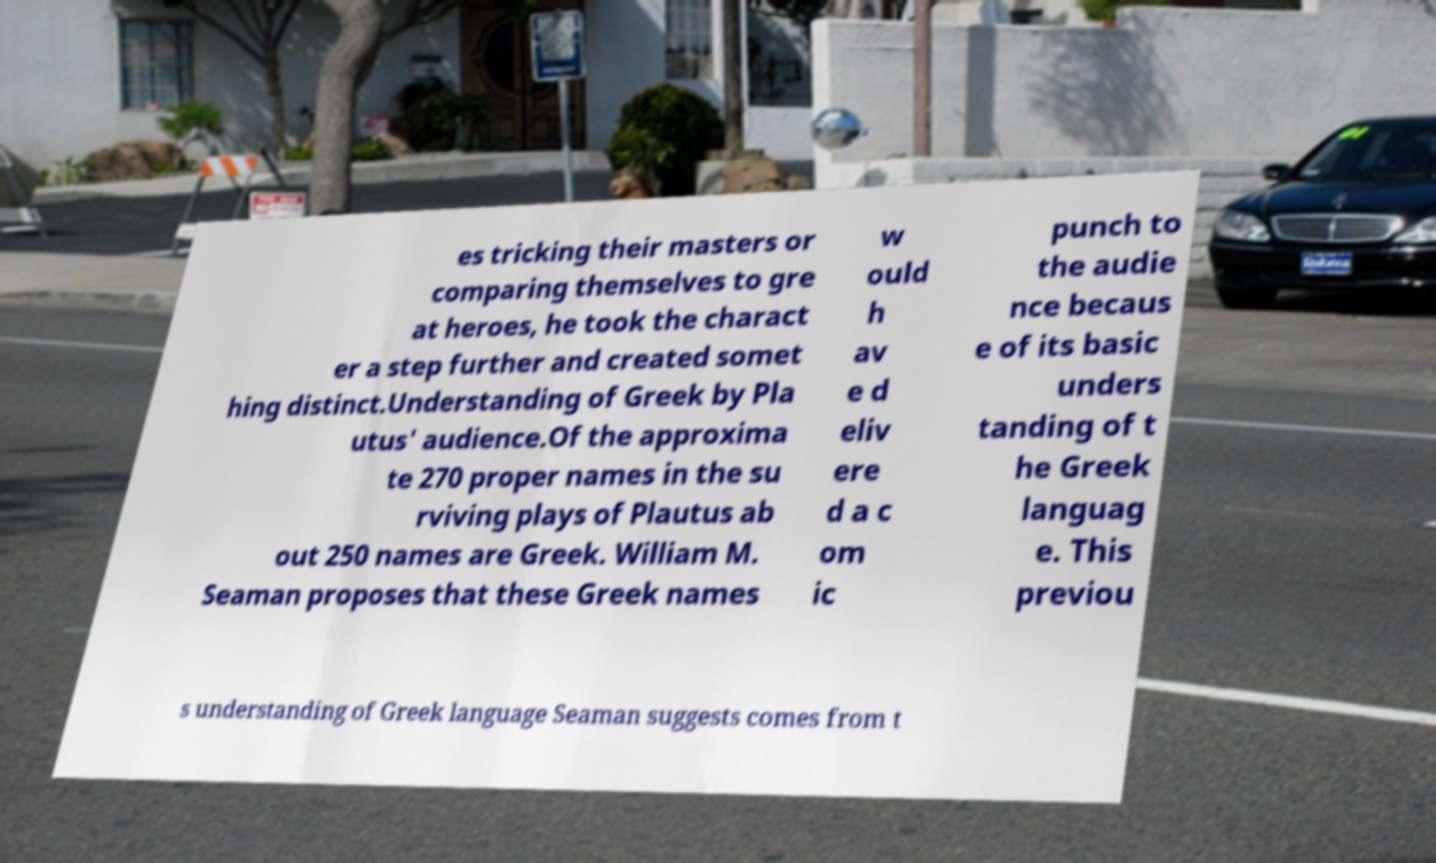Could you assist in decoding the text presented in this image and type it out clearly? es tricking their masters or comparing themselves to gre at heroes, he took the charact er a step further and created somet hing distinct.Understanding of Greek by Pla utus' audience.Of the approxima te 270 proper names in the su rviving plays of Plautus ab out 250 names are Greek. William M. Seaman proposes that these Greek names w ould h av e d eliv ere d a c om ic punch to the audie nce becaus e of its basic unders tanding of t he Greek languag e. This previou s understanding of Greek language Seaman suggests comes from t 